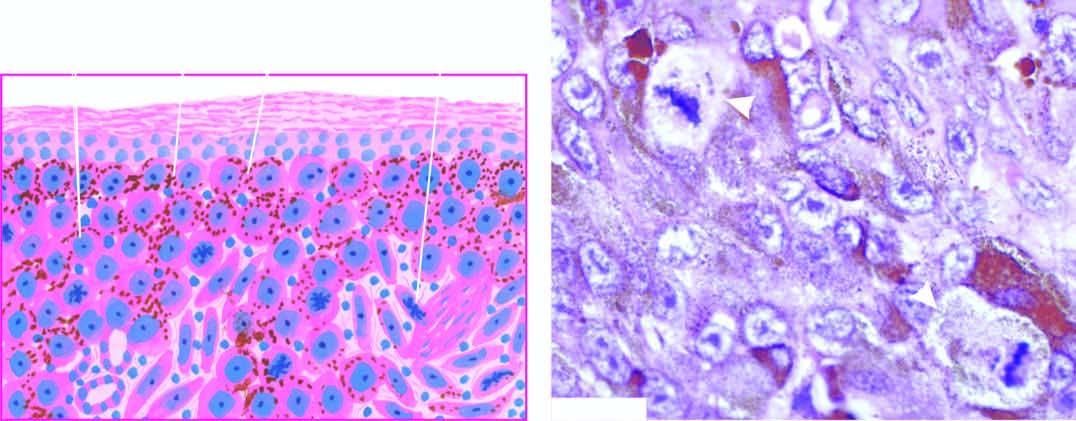what shows junctional activity at the dermal-epidermal junction?
Answer the question using a single word or phrase. Malignant melanoma 